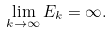Convert formula to latex. <formula><loc_0><loc_0><loc_500><loc_500>\lim _ { k \rightarrow \infty } E _ { k } = \infty .</formula> 